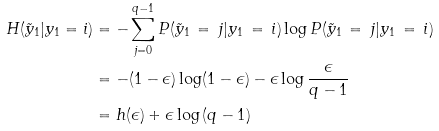Convert formula to latex. <formula><loc_0><loc_0><loc_500><loc_500>H ( \tilde { y } _ { 1 } | y _ { 1 } = i ) & = - \sum _ { j = 0 } ^ { q - 1 } P ( \tilde { y } _ { 1 } \, = \, j | y _ { 1 } \, = \, i ) \log P ( \tilde { y } _ { 1 } \, = \, j | y _ { 1 } \, = \, i ) \\ & = - ( 1 - \epsilon ) \log ( 1 - \epsilon ) - \epsilon \log \frac { \epsilon } { q - 1 } \\ & = h ( \epsilon ) + \epsilon \log \left ( q - 1 \right )</formula> 